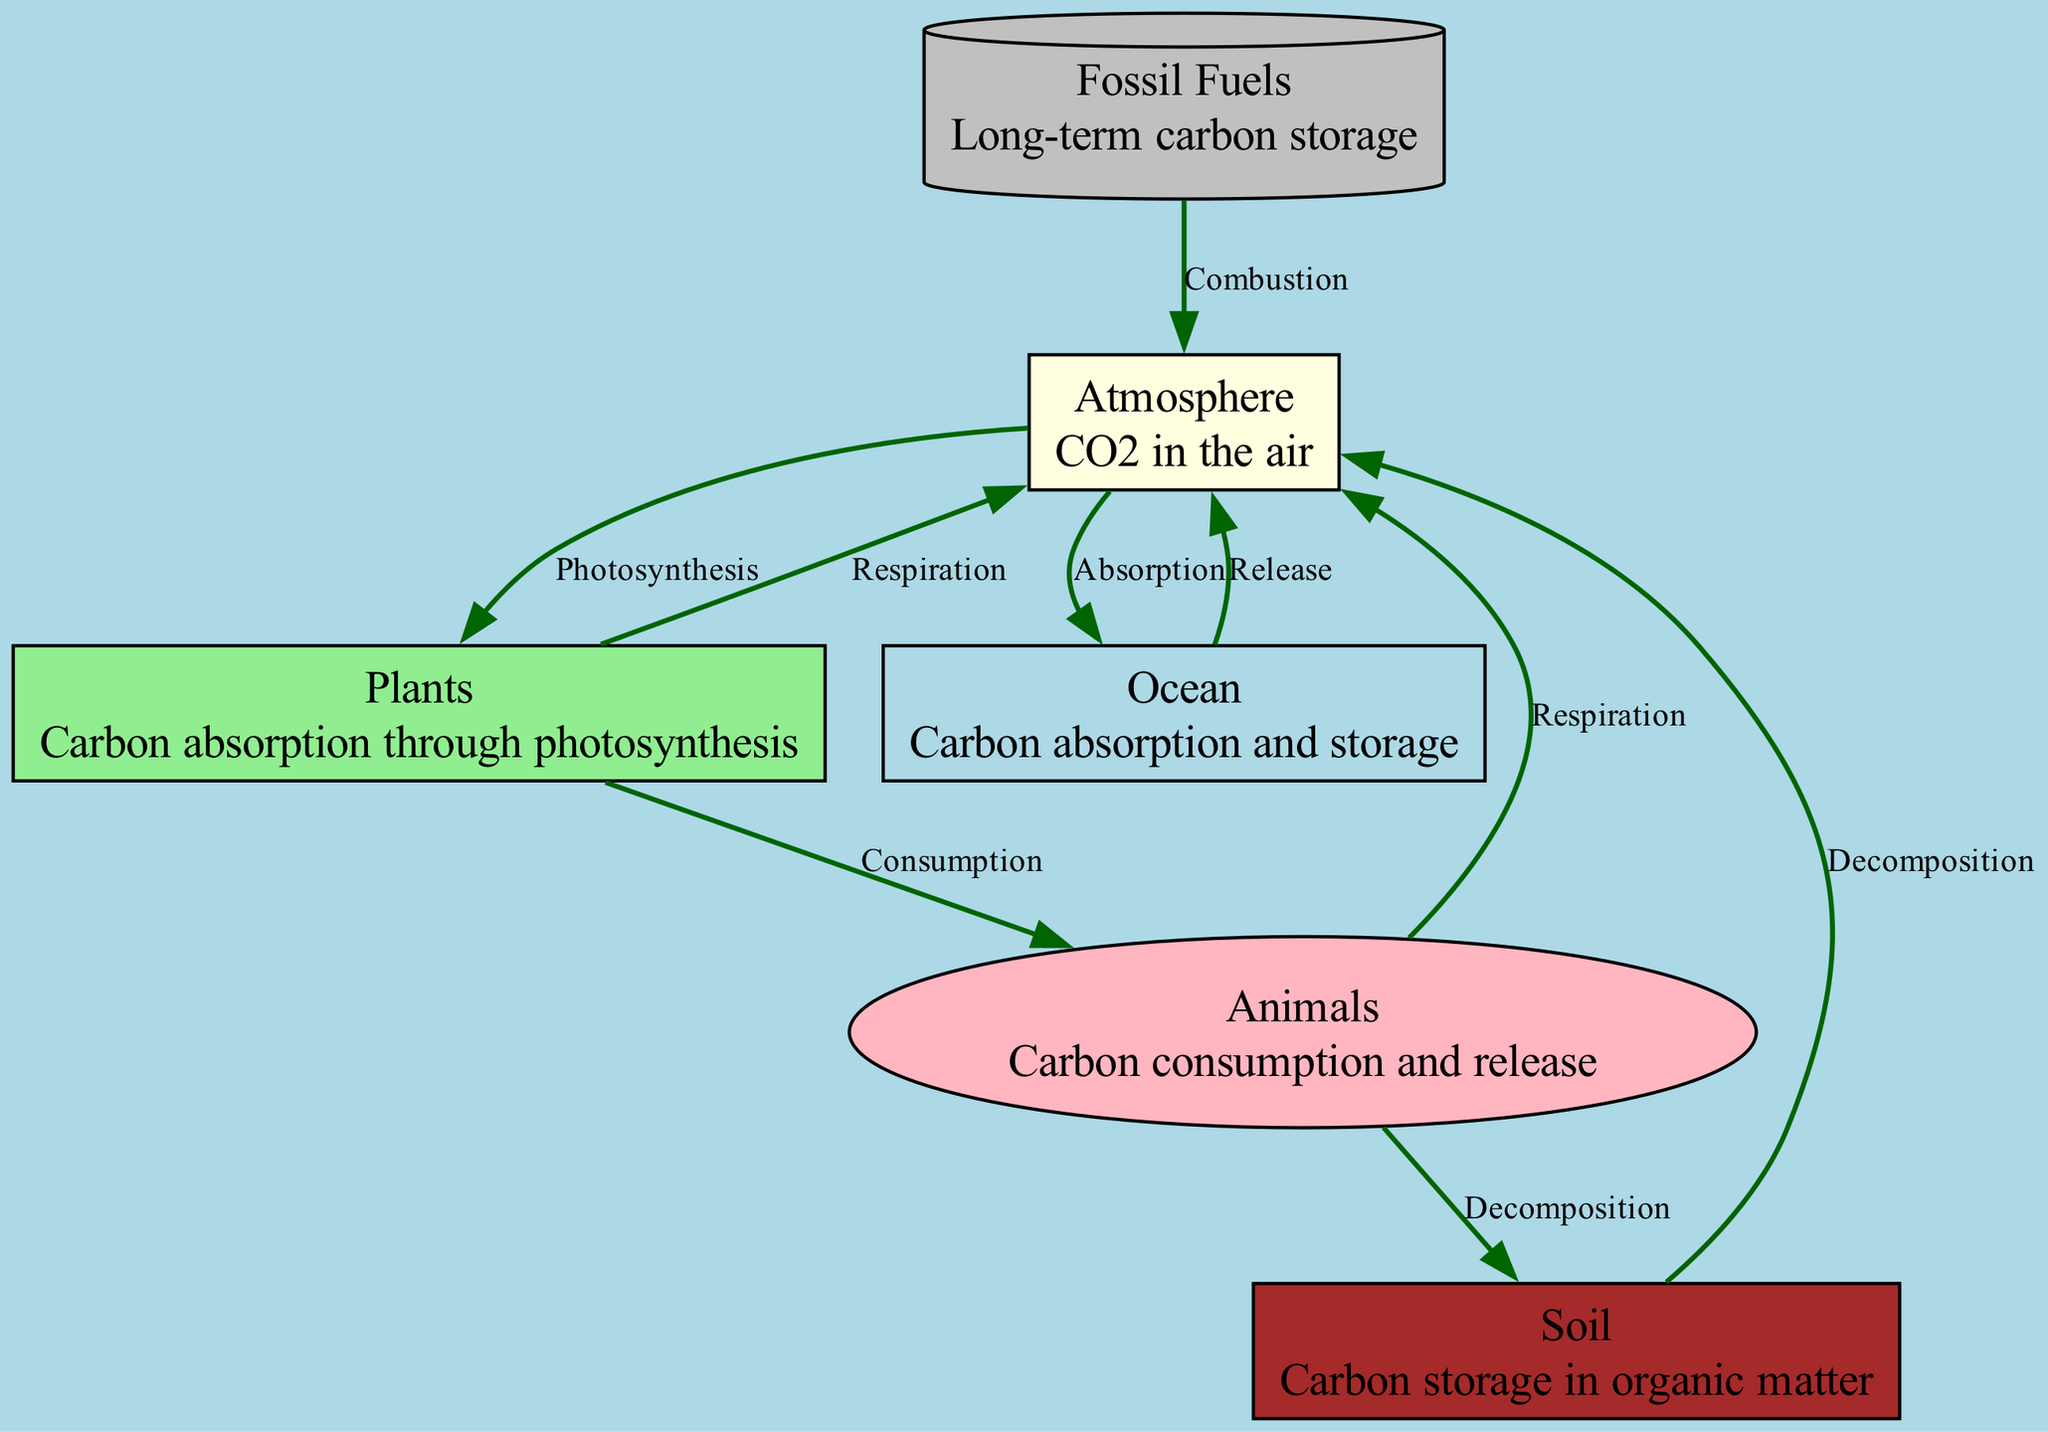What are the nodes in this diagram? The diagram shows six nodes: Atmosphere, Plants, Animals, Soil, Ocean, and Fossil Fuels. Each of these nodes represents different components involved in the carbon cycle.
Answer: Atmosphere, Plants, Animals, Soil, Ocean, Fossil Fuels How many edges are there in the carbon cycle diagram? By counting the connections between the nodes (the edges), we find there are a total of 8 edges represented in the diagram, indicating various interactions in the carbon cycle.
Answer: 8 What process connects Animals to the Atmosphere? The diagram indicates that Animals release carbon into the Atmosphere through the process of Respiration, represented as an edge between these two nodes.
Answer: Respiration Which node stores carbon in organic matter? The Soil node is specifically described as storing carbon in organic matter, highlighting its role in the carbon cycle as a storage medium.
Answer: Soil What is the relationship between the Ocean and the Atmosphere? The Ocean absorbs carbon from the Atmosphere, as indicated by the edge labeled Absorption, while it can also release carbon back into the Atmosphere, represented by the edge labeled Release.
Answer: Absorption and Release How do Plants contribute to the carbon cycle? Plants absorb carbon dioxide from the Atmosphere and convert it through Photosynthesis into energy, while they also release some carbon back into the Atmosphere via Respiration. This highlights their dual role in the carbon cycle.
Answer: Photosynthesis & Respiration What happens to carbon during the combustion of Fossil Fuels? The process of Combustion leads to the release of carbon from Fossil Fuels into the Atmosphere, which increases the concentration of carbon dioxide in the air.
Answer: Combustion What does the Decomposition process show in the carbon cycle? Decomposition connects Animals and Soil to the Atmosphere, illustrating how carbon is returned to the Atmosphere through the breakdown of organic matter from Animals and Soil.
Answer: Decomposition What does the interaction between Plants and Animals represent? The interaction between Plants and Animals represents the process of Consumption, where Animals consume Plants, thereby transferring carbon from Plants to Animals in the carbon cycle.
Answer: Consumption 